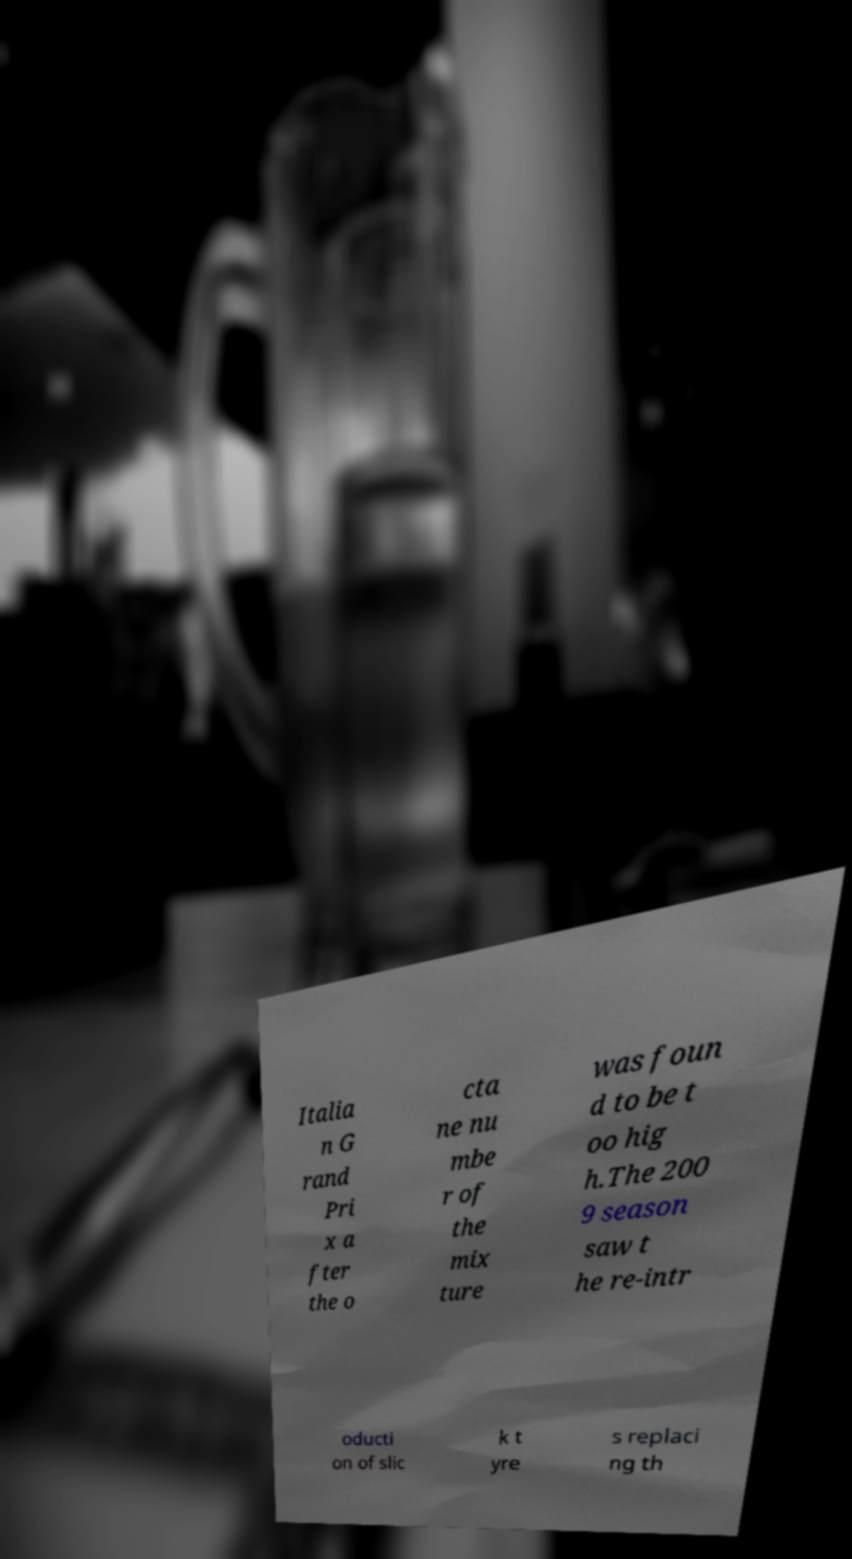What messages or text are displayed in this image? I need them in a readable, typed format. Italia n G rand Pri x a fter the o cta ne nu mbe r of the mix ture was foun d to be t oo hig h.The 200 9 season saw t he re-intr oducti on of slic k t yre s replaci ng th 